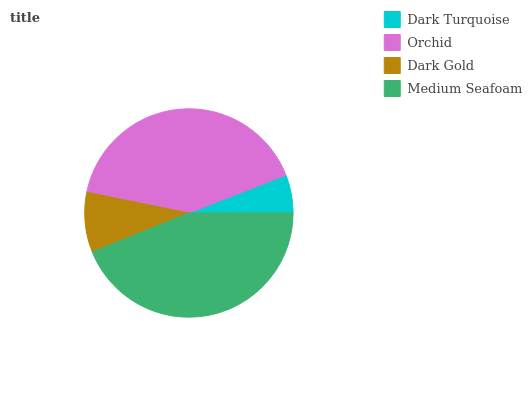Is Dark Turquoise the minimum?
Answer yes or no. Yes. Is Medium Seafoam the maximum?
Answer yes or no. Yes. Is Orchid the minimum?
Answer yes or no. No. Is Orchid the maximum?
Answer yes or no. No. Is Orchid greater than Dark Turquoise?
Answer yes or no. Yes. Is Dark Turquoise less than Orchid?
Answer yes or no. Yes. Is Dark Turquoise greater than Orchid?
Answer yes or no. No. Is Orchid less than Dark Turquoise?
Answer yes or no. No. Is Orchid the high median?
Answer yes or no. Yes. Is Dark Gold the low median?
Answer yes or no. Yes. Is Medium Seafoam the high median?
Answer yes or no. No. Is Dark Turquoise the low median?
Answer yes or no. No. 